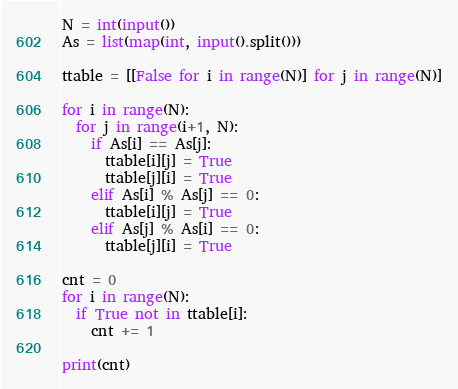<code> <loc_0><loc_0><loc_500><loc_500><_Python_>N = int(input())
As = list(map(int, input().split()))
 
ttable = [[False for i in range(N)] for j in range(N)]
 
for i in range(N):
  for j in range(i+1, N):
    if As[i] == As[j]:
      ttable[i][j] = True
      ttable[j][i] = True
    elif As[i] % As[j] == 0:
      ttable[i][j] = True
    elif As[j] % As[i] == 0:
      ttable[j][i] = True

cnt = 0
for i in range(N):
  if True not in ttable[i]:
    cnt += 1

print(cnt)</code> 